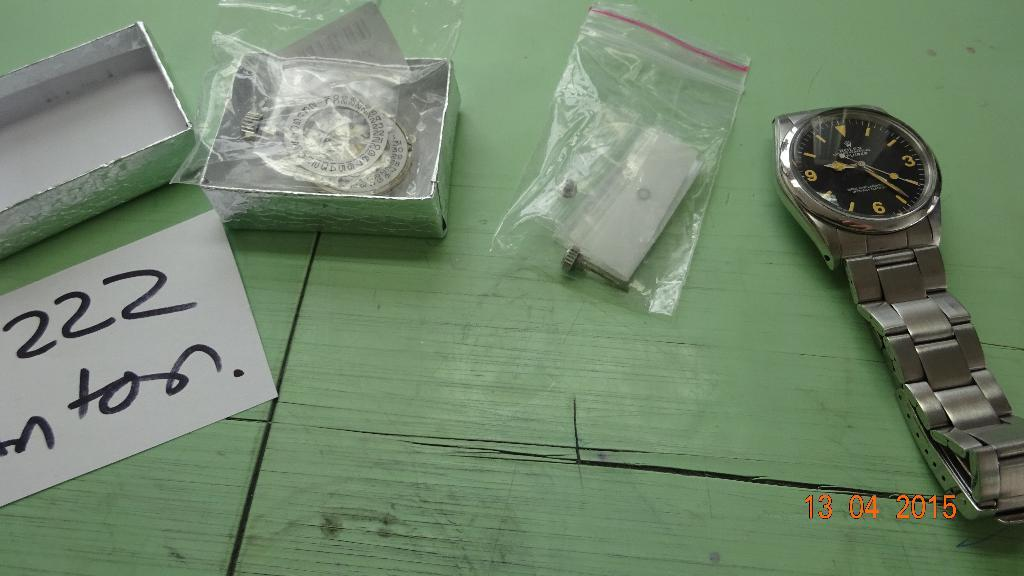<image>
Create a compact narrative representing the image presented. Wristwatch on a table with a white paper that says "222" on it. 